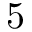<formula> <loc_0><loc_0><loc_500><loc_500>5</formula> 